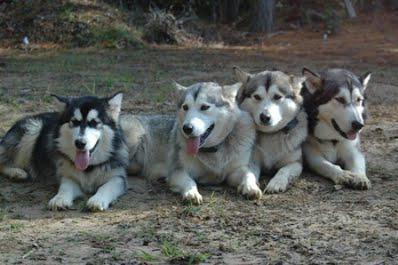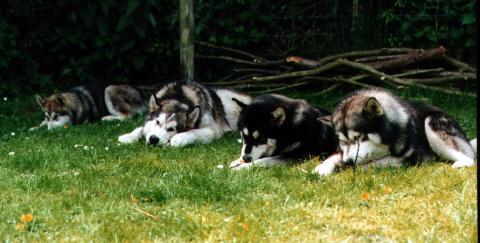The first image is the image on the left, the second image is the image on the right. Analyze the images presented: Is the assertion "At least one of the dogs in the image on the left is wearing a vest." valid? Answer yes or no. No. The first image is the image on the left, the second image is the image on the right. For the images displayed, is the sentence "In at least one image there is a single dog facing left that is trying to pull a stack of cement bricks." factually correct? Answer yes or no. No. 